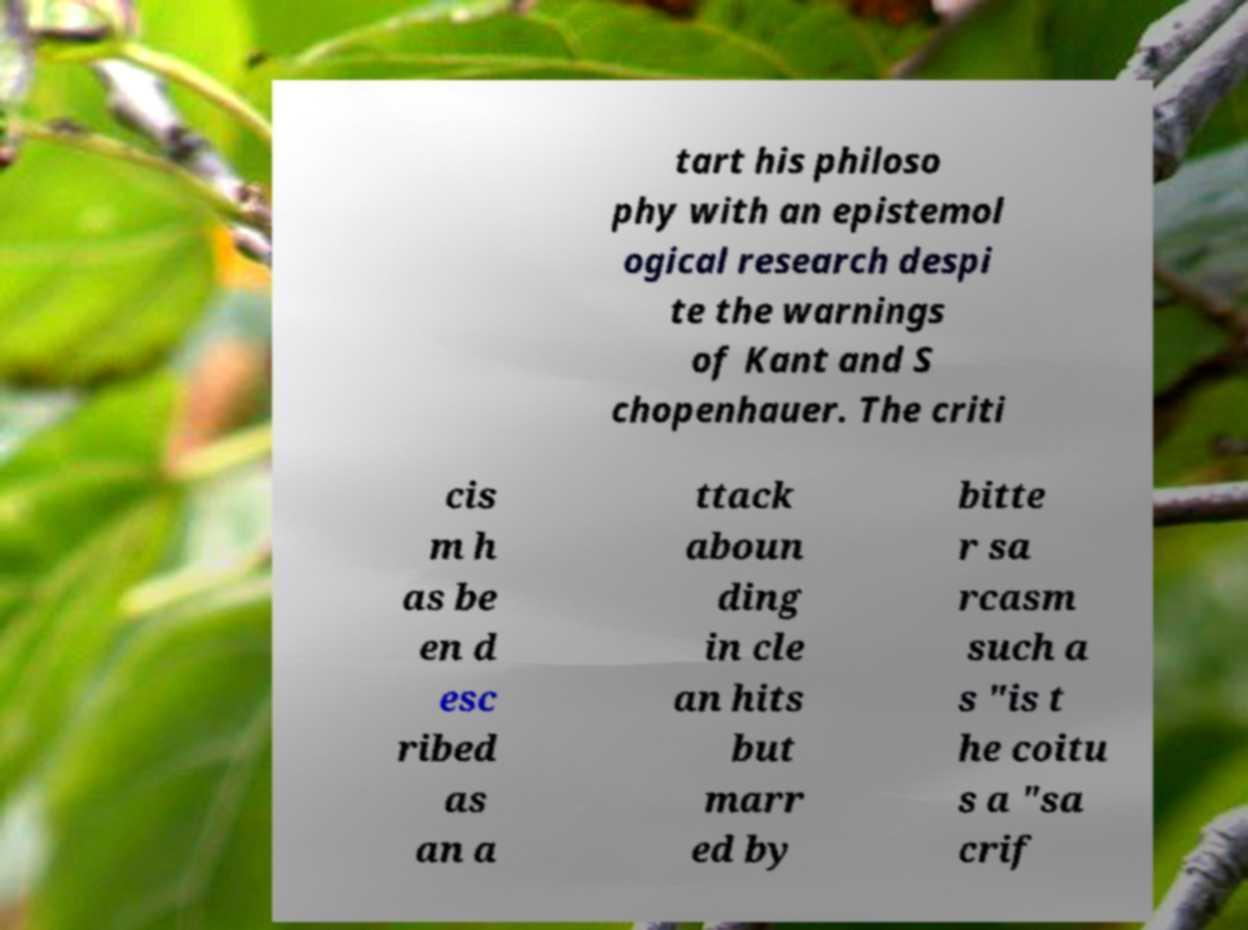What messages or text are displayed in this image? I need them in a readable, typed format. tart his philoso phy with an epistemol ogical research despi te the warnings of Kant and S chopenhauer. The criti cis m h as be en d esc ribed as an a ttack aboun ding in cle an hits but marr ed by bitte r sa rcasm such a s "is t he coitu s a "sa crif 